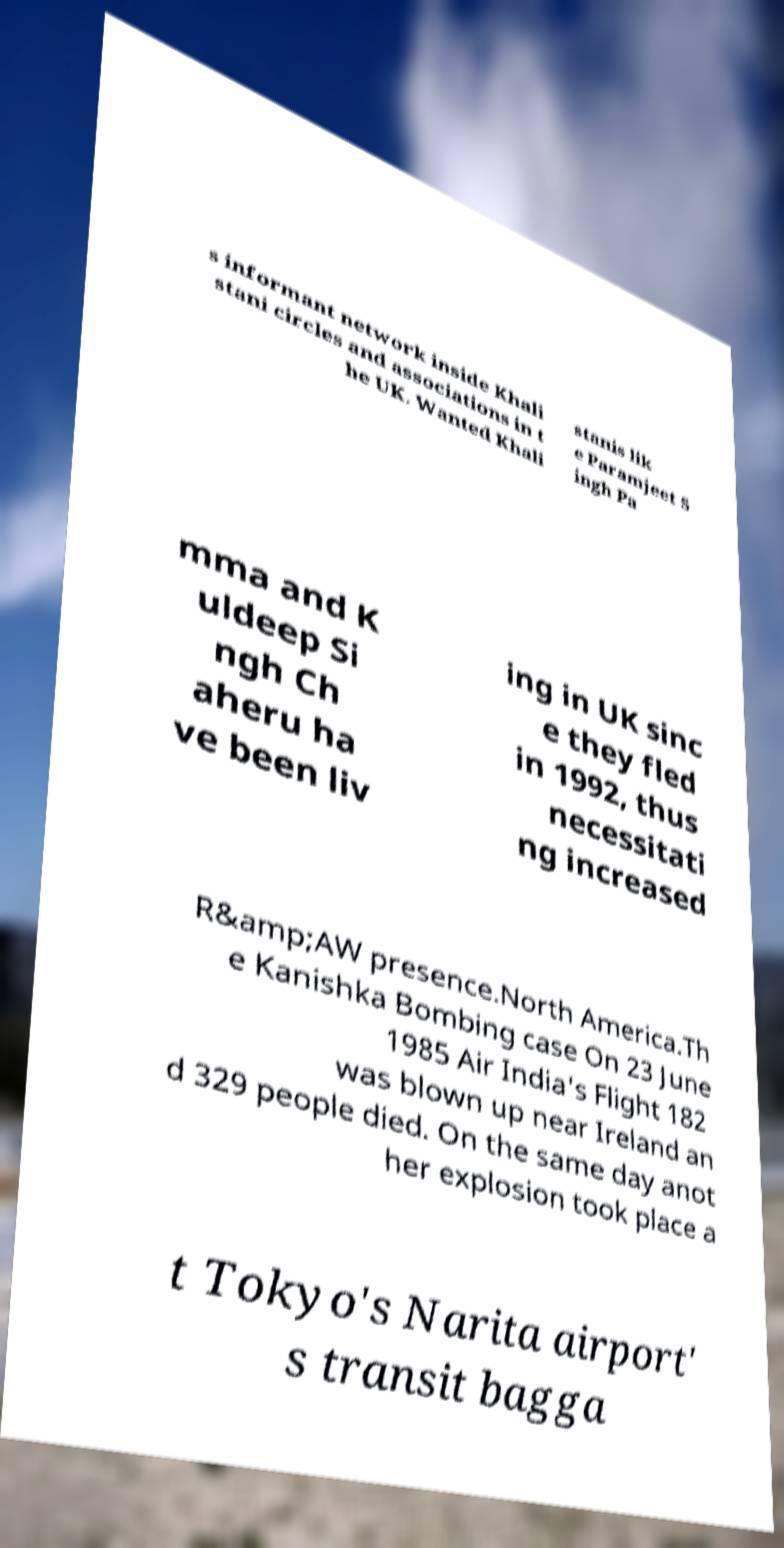Please identify and transcribe the text found in this image. s informant network inside Khali stani circles and associations in t he UK. Wanted Khali stanis lik e Paramjeet S ingh Pa mma and K uldeep Si ngh Ch aheru ha ve been liv ing in UK sinc e they fled in 1992, thus necessitati ng increased R&amp;AW presence.North America.Th e Kanishka Bombing case On 23 June 1985 Air India's Flight 182 was blown up near Ireland an d 329 people died. On the same day anot her explosion took place a t Tokyo's Narita airport' s transit bagga 